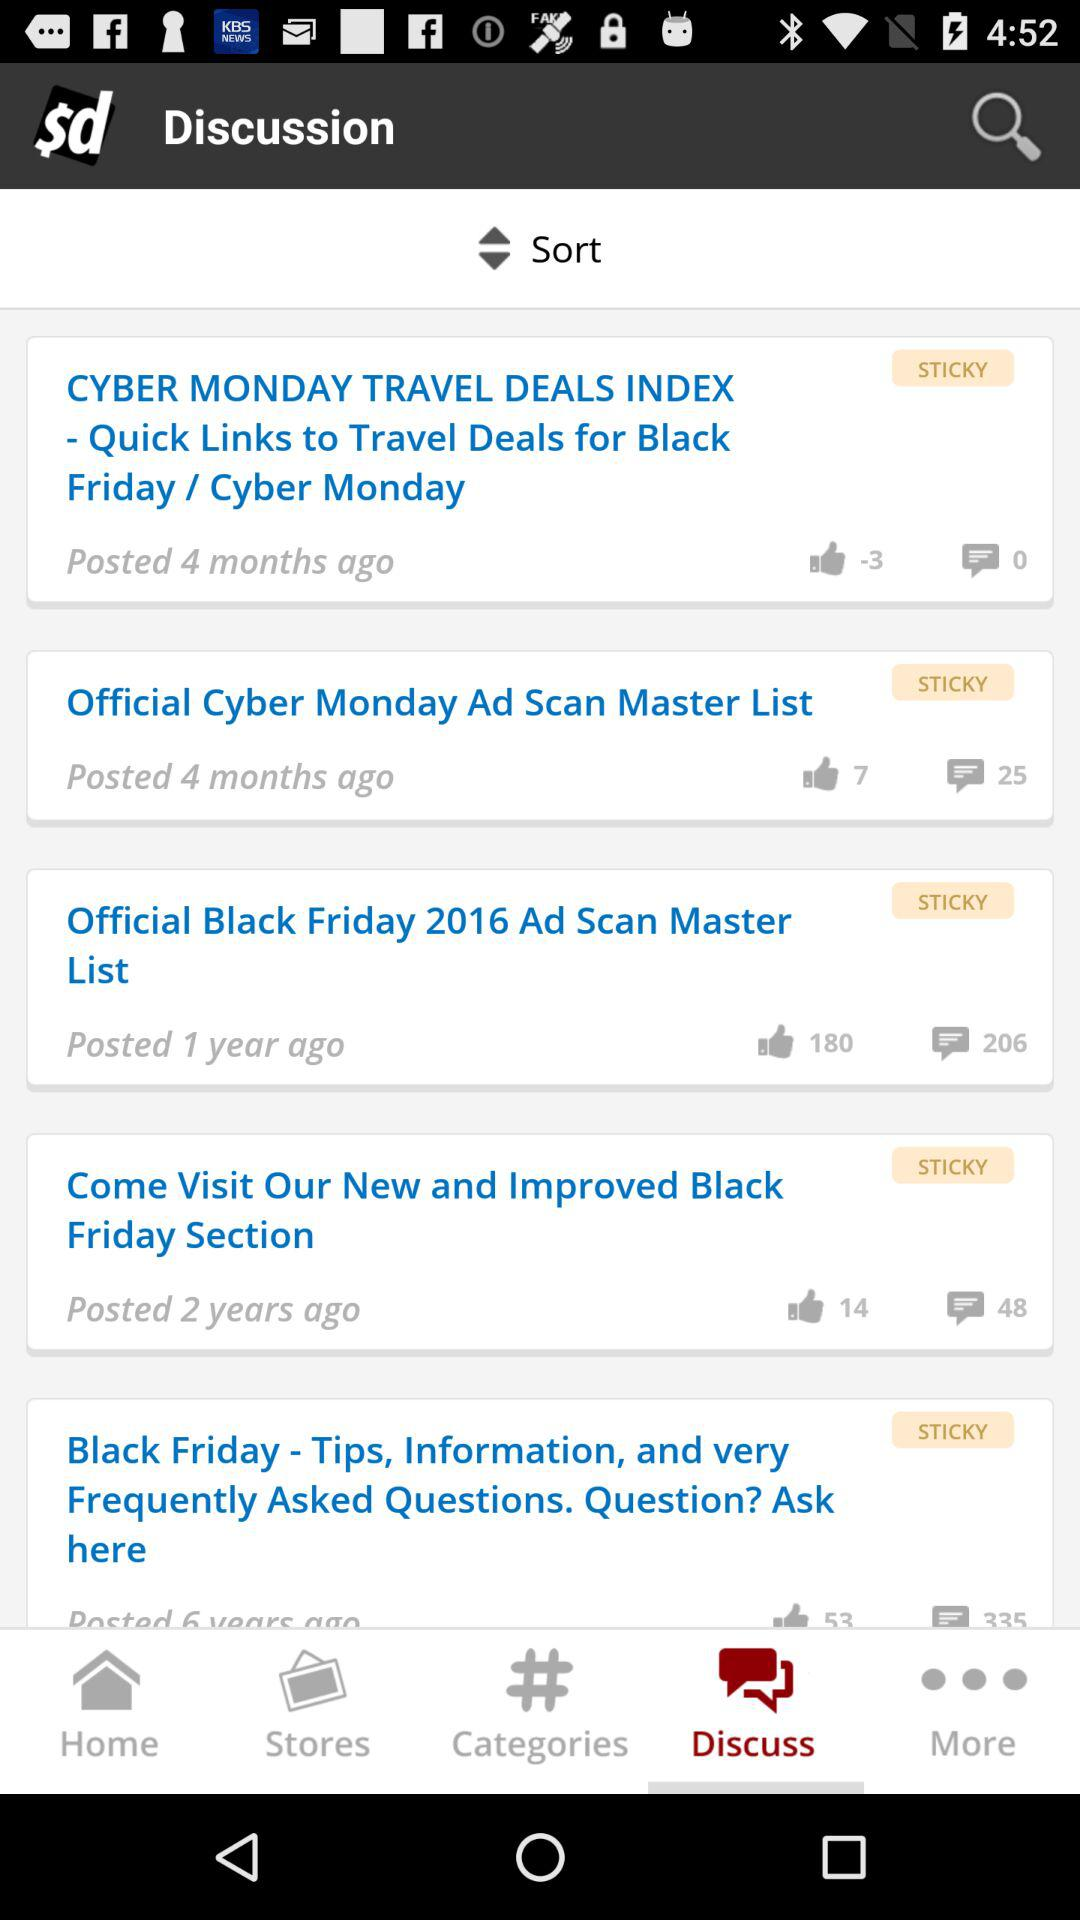Which post has negative likes? The post that has negative likes is "CYBER MONDAY TRAVEL DEALS INDEX - Quick Links to Travel Deals for Black Friday / Cyber Monday". 